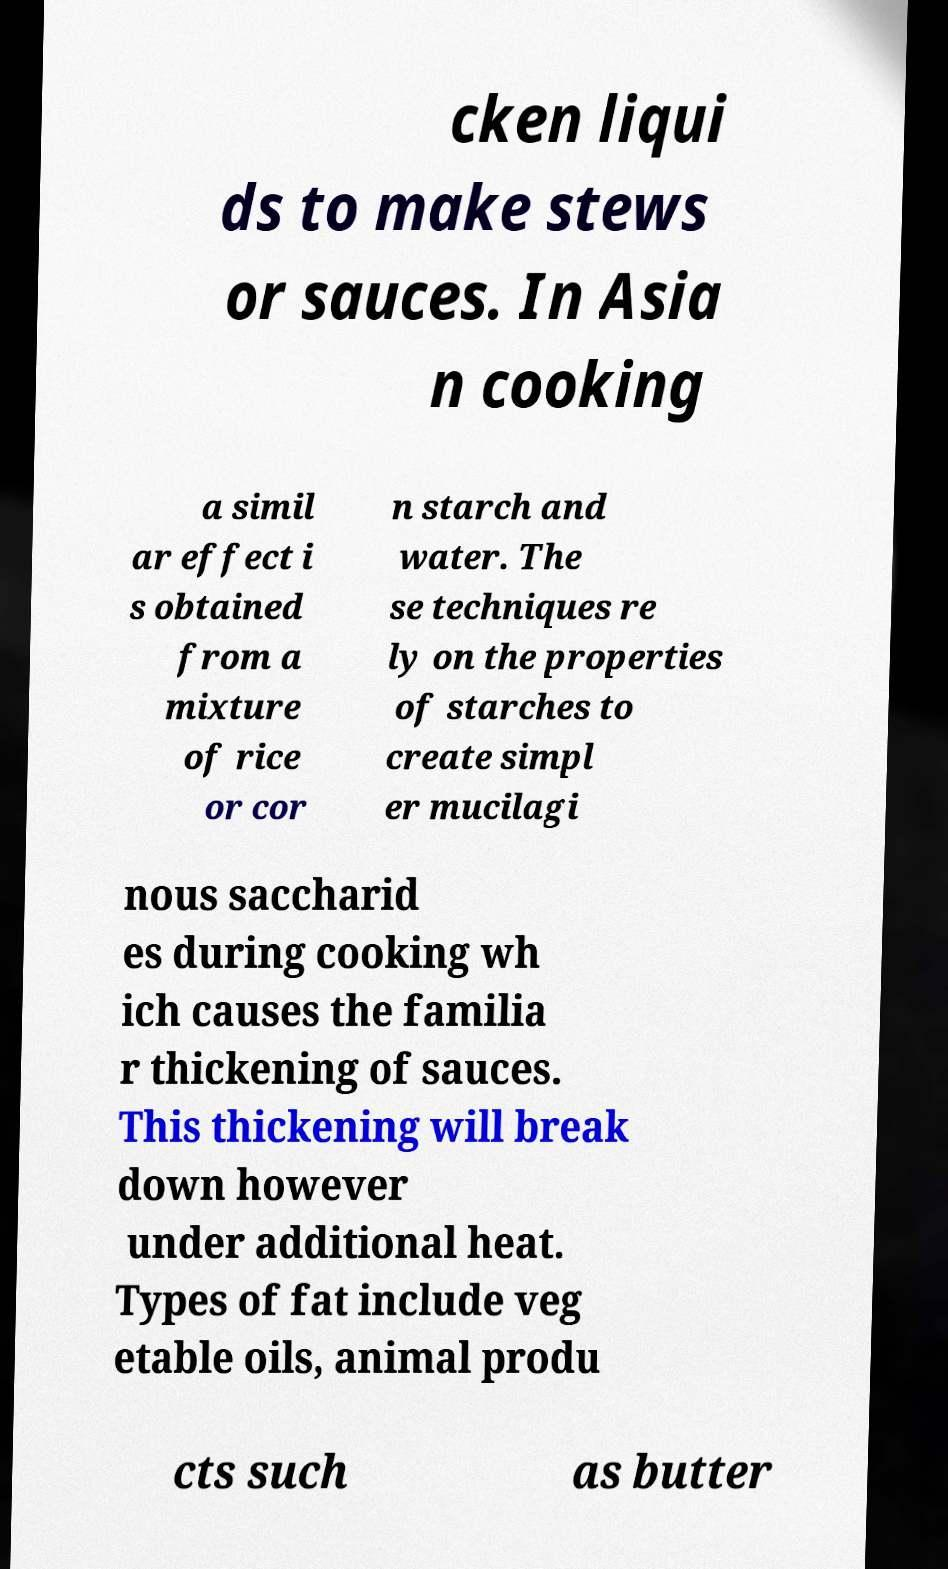What messages or text are displayed in this image? I need them in a readable, typed format. cken liqui ds to make stews or sauces. In Asia n cooking a simil ar effect i s obtained from a mixture of rice or cor n starch and water. The se techniques re ly on the properties of starches to create simpl er mucilagi nous saccharid es during cooking wh ich causes the familia r thickening of sauces. This thickening will break down however under additional heat. Types of fat include veg etable oils, animal produ cts such as butter 